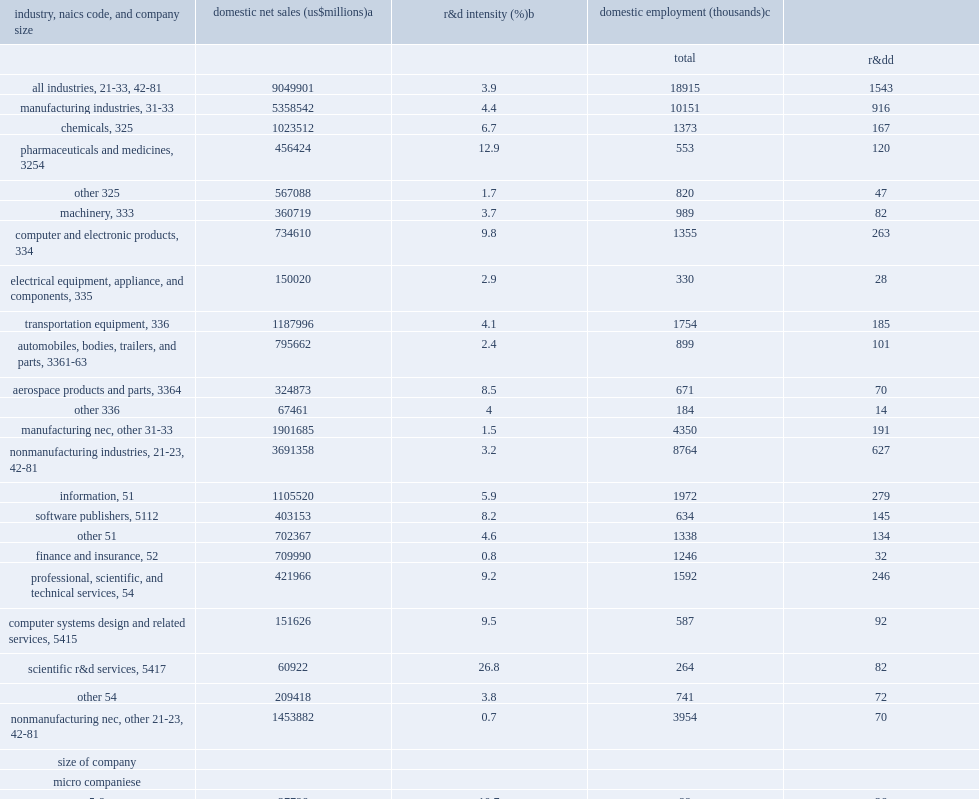How many percent did the largest companies (25,000 or more domestic employees) perform of the nation's total business r&d in 2015? 0.413261. What was the r&d intensity of the largest companies (25,000 or more domestic employees)? 3.4. How many percent of employees did the largest companies (25,000 or more domestic employees) employ who worked for r&d-performing or r&d-funding companies? 4.1. How many percent of r&d employees did the largest companies (25,000 or more domestic employees) employ in the united states? 0.260531. 